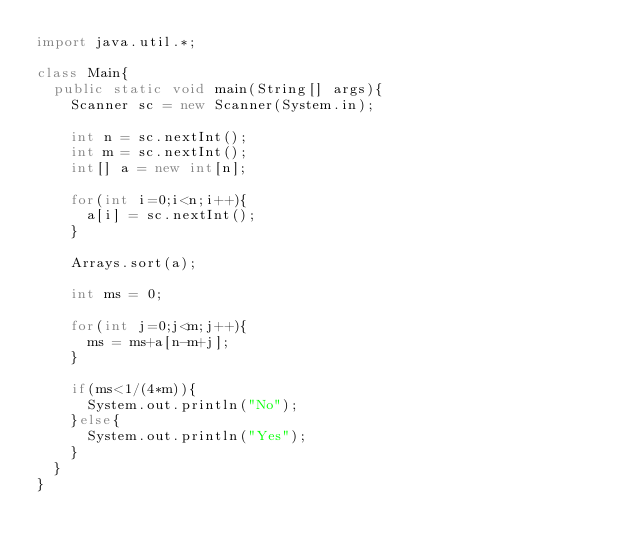Convert code to text. <code><loc_0><loc_0><loc_500><loc_500><_Java_>import java.util.*;
 
class Main{
  public static void main(String[] args){
    Scanner sc = new Scanner(System.in);
    
    int n = sc.nextInt();
    int m = sc.nextInt();
    int[] a = new int[n];
    
    for(int i=0;i<n;i++){
      a[i] = sc.nextInt();
    }
    
    Arrays.sort(a);
    
    int ms = 0;
    
    for(int j=0;j<m;j++){
      ms = ms+a[n-m+j];
    }
    
    if(ms<1/(4*m)){
      System.out.println("No");
    }else{
      System.out.println("Yes");
    }
  }
}</code> 